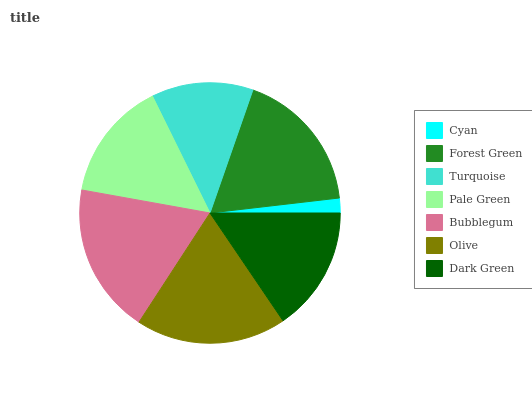Is Cyan the minimum?
Answer yes or no. Yes. Is Bubblegum the maximum?
Answer yes or no. Yes. Is Forest Green the minimum?
Answer yes or no. No. Is Forest Green the maximum?
Answer yes or no. No. Is Forest Green greater than Cyan?
Answer yes or no. Yes. Is Cyan less than Forest Green?
Answer yes or no. Yes. Is Cyan greater than Forest Green?
Answer yes or no. No. Is Forest Green less than Cyan?
Answer yes or no. No. Is Dark Green the high median?
Answer yes or no. Yes. Is Dark Green the low median?
Answer yes or no. Yes. Is Olive the high median?
Answer yes or no. No. Is Olive the low median?
Answer yes or no. No. 